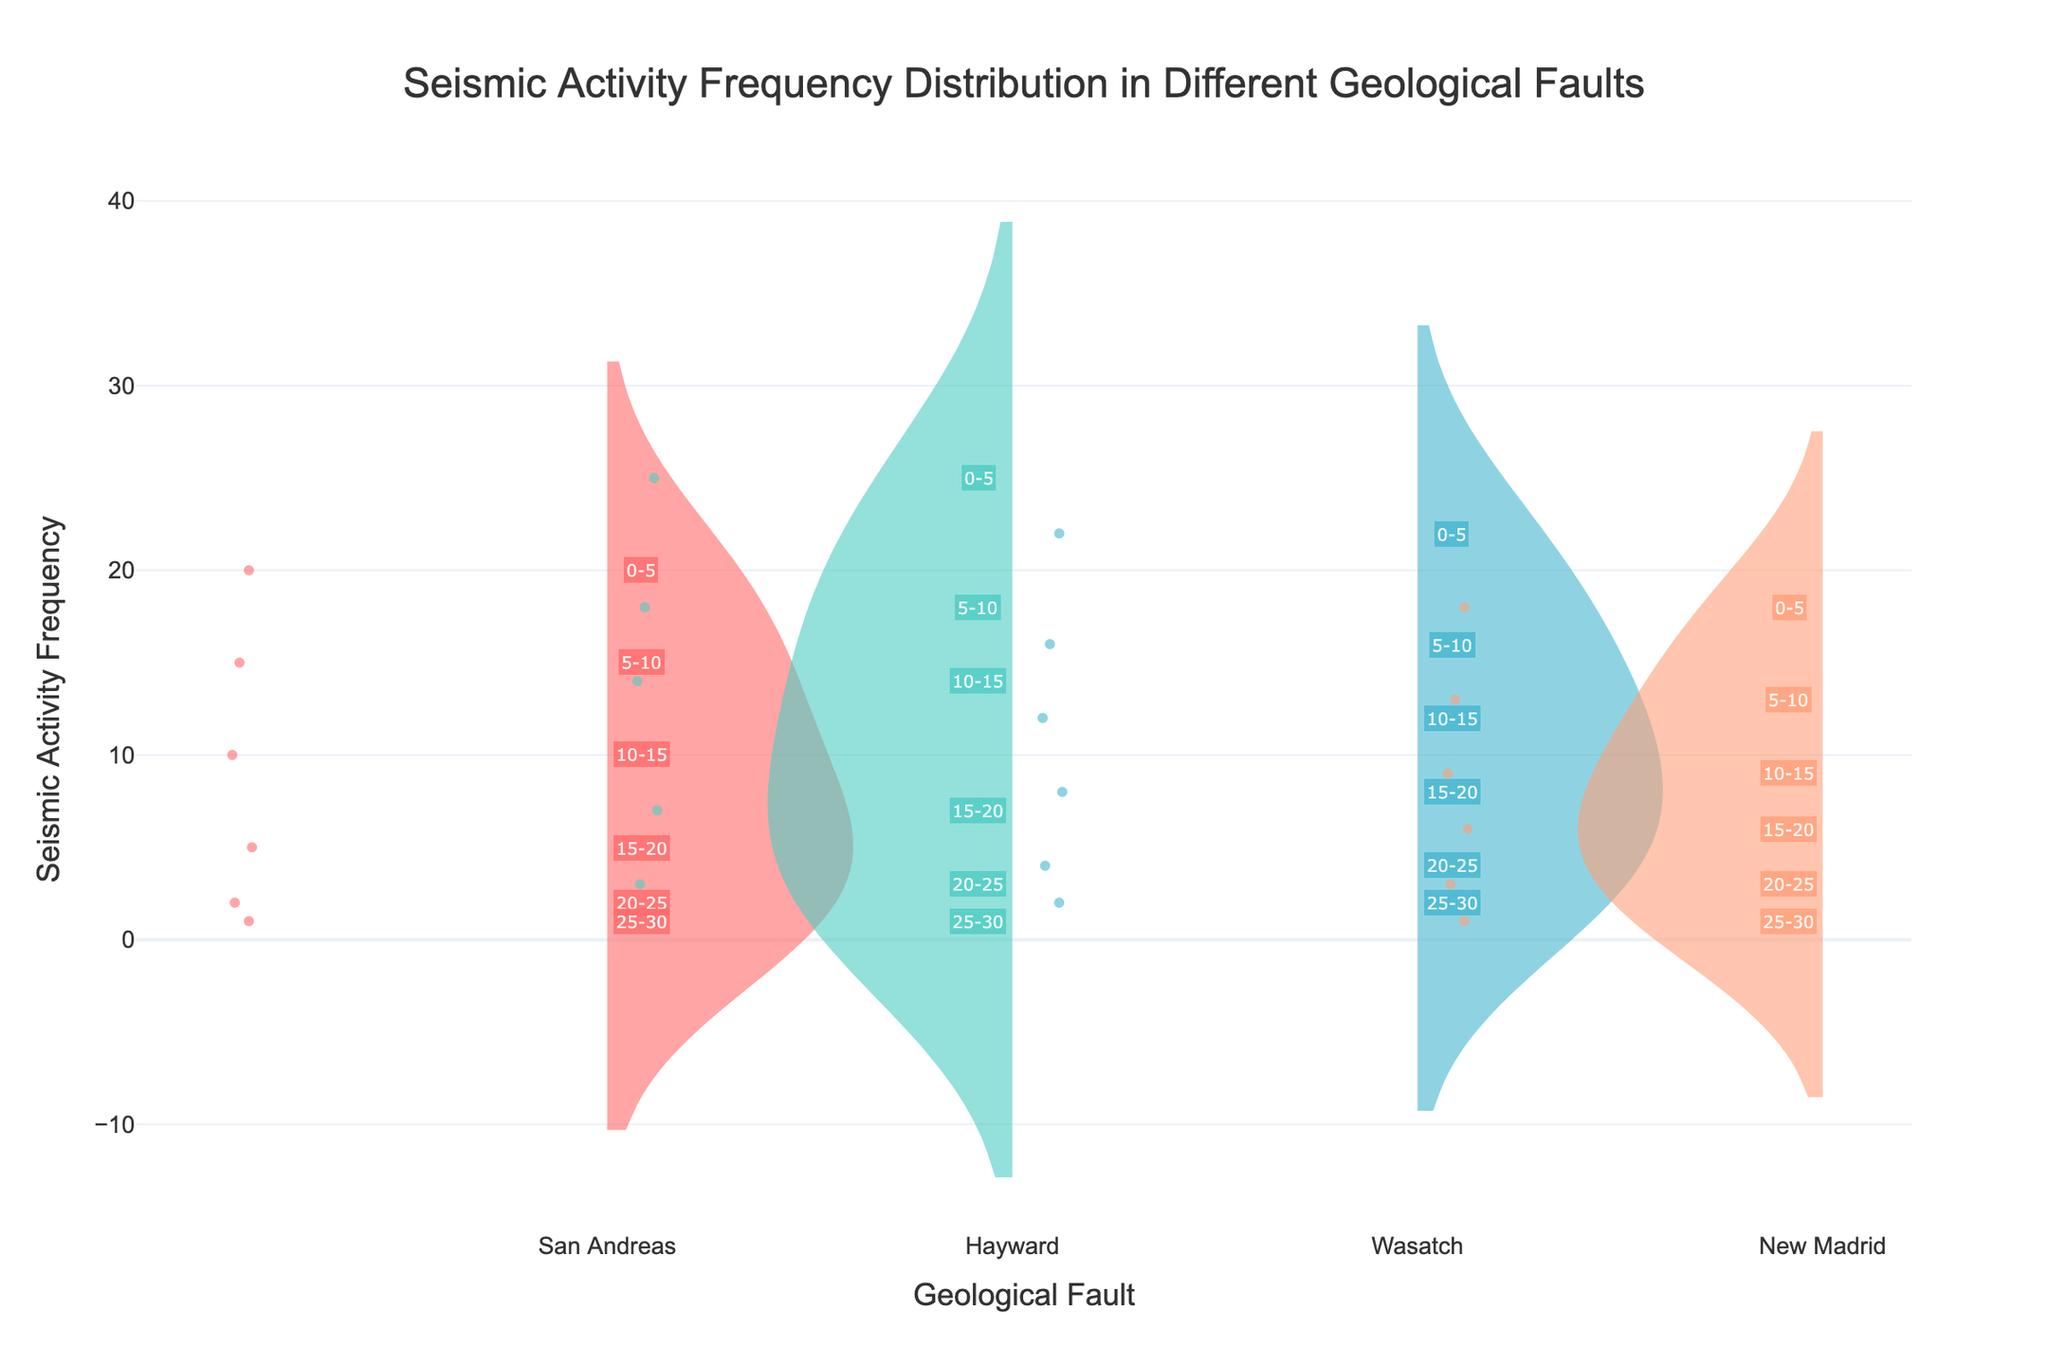What is the title of the figure? The title is usually displayed at the top of the figure. In this case, it indicates the main topic of the chart.
Answer: Seismic Activity Frequency Distribution in Different Geological Faults What does the x-axis represent? The x-axis labels represent the different geological faults under study.
Answer: Geological Fault How many seismic activity frequency data points are there for the San Andreas fault? By observing the number of points present along the y-axis for the San Andreas fault, we can determine the count.
Answer: 6 Which fault shows the highest seismic activity frequency at 0-5 km depth? The topmost point of each violin plot represents the seismic activity frequency at 0-5 km depth. The fault with the highest point is the answer.
Answer: Hayward What is the seismic activity frequency at 20-25 km depth for the New Madrid fault? Each depth value is annotated next to the seismic activity frequency points. Identify the annotation for "New Madrid" at 20-25 km depth.
Answer: 3 On average, which fault exhibits the highest overall seismic activity frequency? Consider the central tendencies of the violin plots (meanlines) for each fault to deduce which one has the highest overall values.
Answer: Hayward What is the difference in seismic activity frequency between the shallowest (0-5 km) and deepest (25-30 km) depths for the Wasatch fault? Identify the seismic activity frequency points for Wasatch at 0-5 km and 25-30 km depths, then subtract the latter from the former.
Answer: 20 Which fault has the steepest decrease in seismic activity frequency from 0-5 km to 5-10 km depths? Compare the differences in seismic activity frequency from 0-5 km to 5-10 km for each fault; the one with the greatest change is the answer.
Answer: San Andreas How does the maximum seismic activity frequency of Hayward fault compare to that of New Madrid fault? Compare the highest data points on the violin plots of Hayward and New Madrid faults.
Answer: Higher Are the seismic activity frequencies at depths greater than 20 km generally higher or lower across all faults? Examine the lower regions of all violin plots to determine if frequencies at depths greater than 20 km are generally lower or higher.
Answer: Lower 